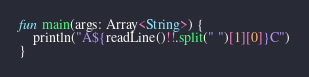<code> <loc_0><loc_0><loc_500><loc_500><_Kotlin_>fun main(args: Array<String>) {
    println("A${readLine()!!.split(" ")[1][0]}C")
}
</code> 